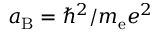Convert formula to latex. <formula><loc_0><loc_0><loc_500><loc_500>a _ { B } = \hbar { ^ } { 2 } / m _ { e } e ^ { 2 }</formula> 